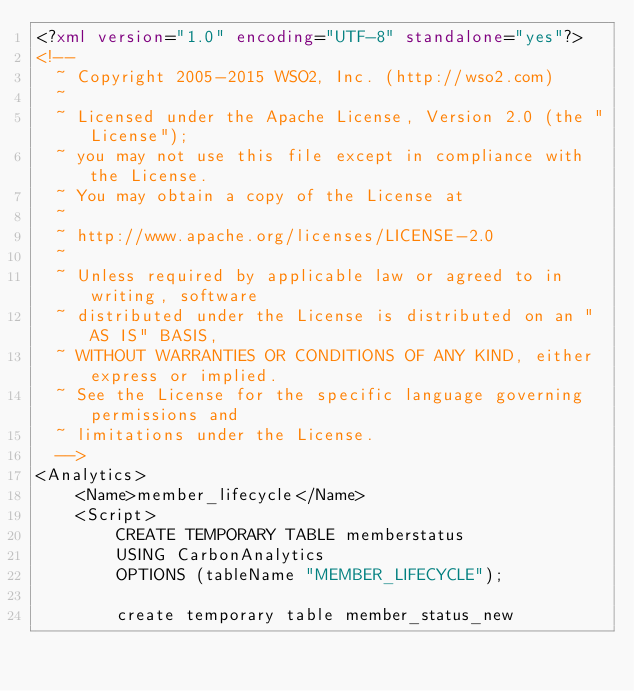<code> <loc_0><loc_0><loc_500><loc_500><_XML_><?xml version="1.0" encoding="UTF-8" standalone="yes"?>
<!--
  ~ Copyright 2005-2015 WSO2, Inc. (http://wso2.com)
  ~
  ~ Licensed under the Apache License, Version 2.0 (the "License");
  ~ you may not use this file except in compliance with the License.
  ~ You may obtain a copy of the License at
  ~
  ~ http://www.apache.org/licenses/LICENSE-2.0
  ~
  ~ Unless required by applicable law or agreed to in writing, software
  ~ distributed under the License is distributed on an "AS IS" BASIS,
  ~ WITHOUT WARRANTIES OR CONDITIONS OF ANY KIND, either express or implied.
  ~ See the License for the specific language governing permissions and
  ~ limitations under the License.
  -->
<Analytics>
    <Name>member_lifecycle</Name>
    <Script>
        CREATE TEMPORARY TABLE memberstatus
        USING CarbonAnalytics
        OPTIONS (tableName "MEMBER_LIFECYCLE");

        create temporary table member_status_new</code> 